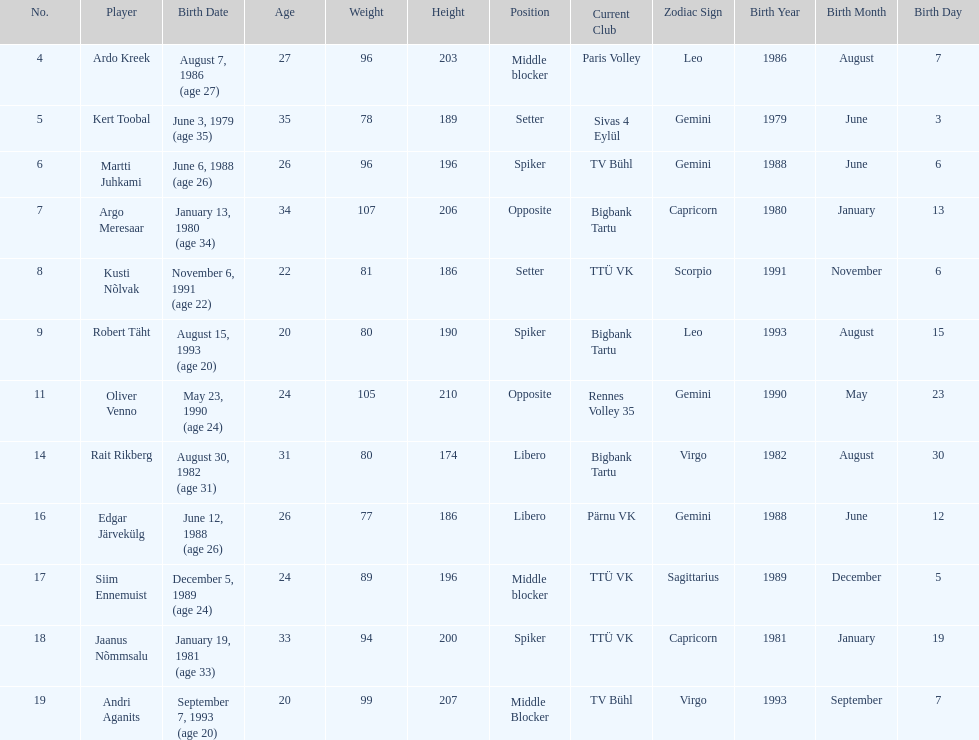Who were the players that played in the same position as ardo kreek? Siim Ennemuist, Andri Aganits. 